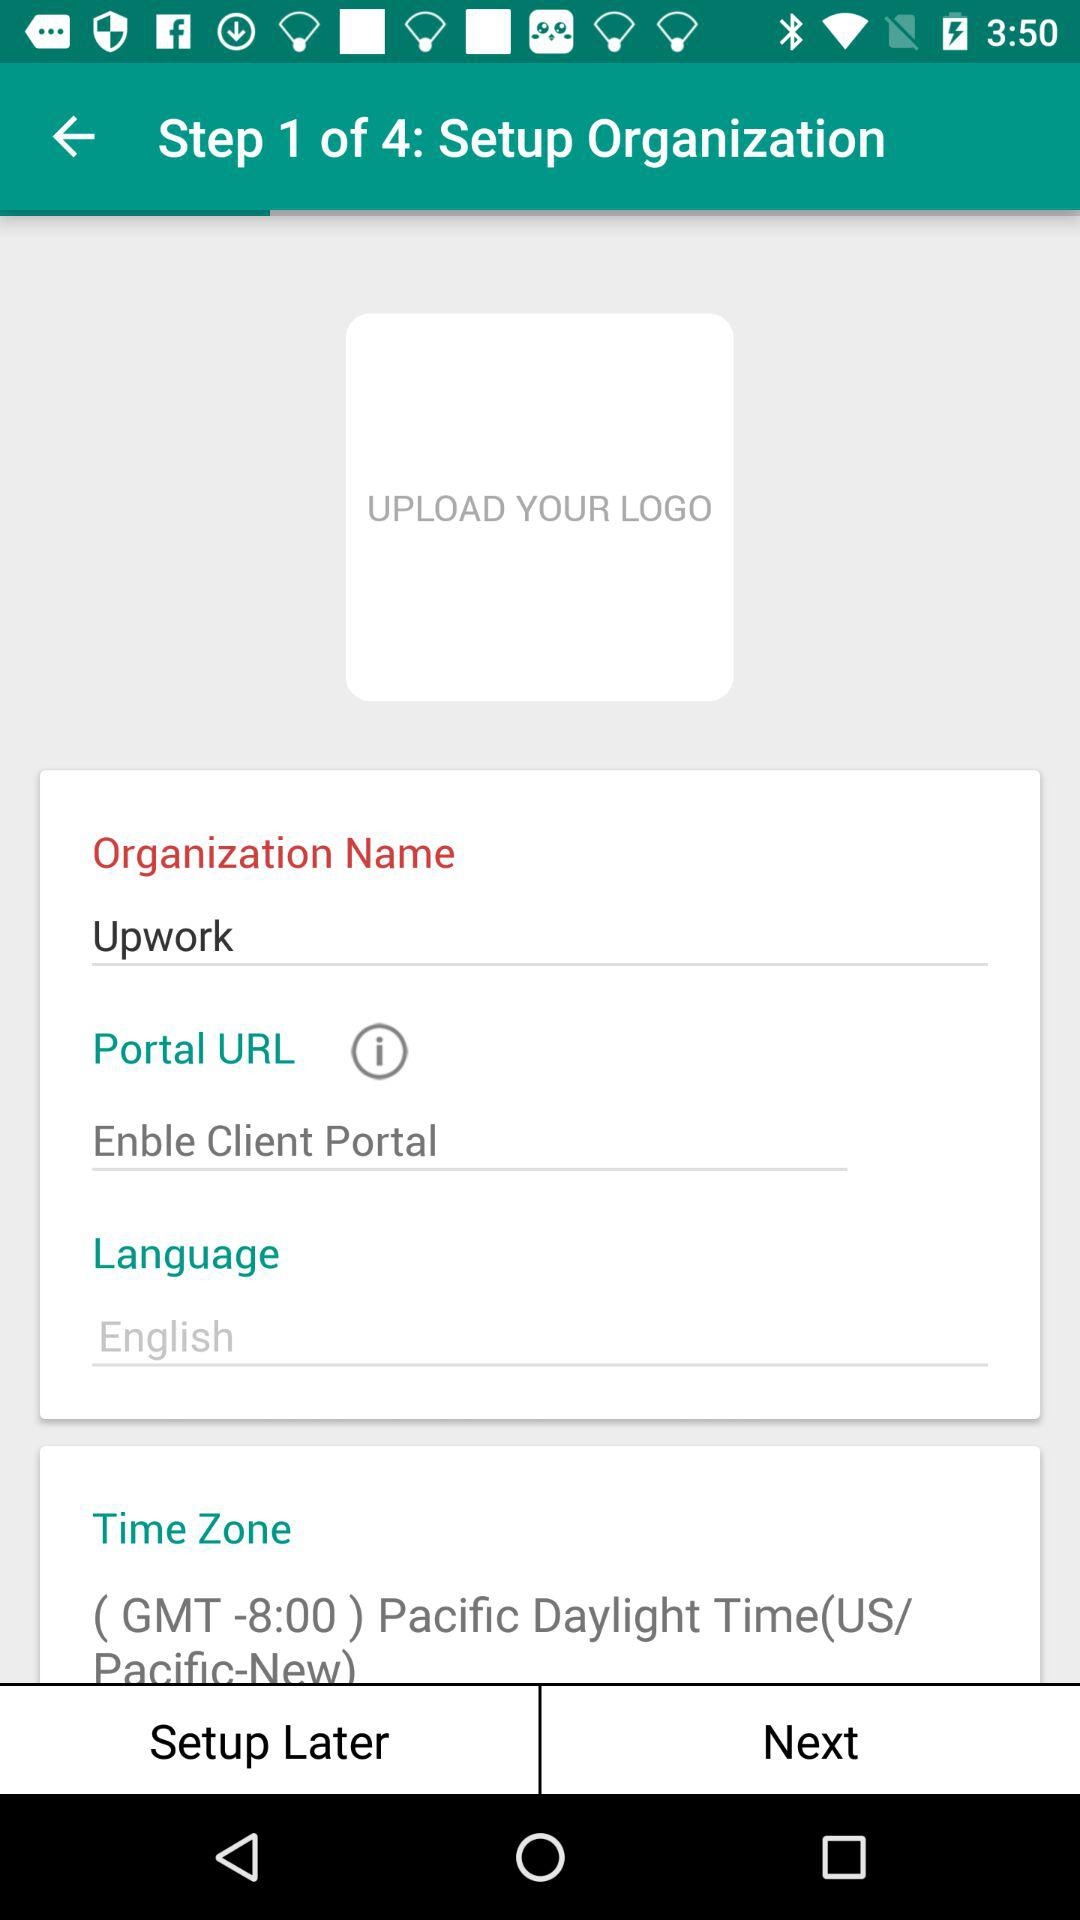Which language is mentioned? The mentioned language is English. 